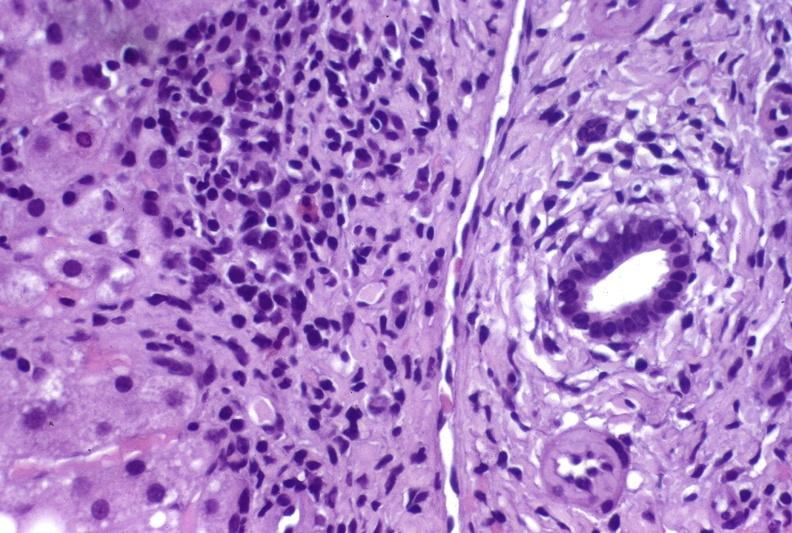does myocardium show hepatitis c virus?
Answer the question using a single word or phrase. No 